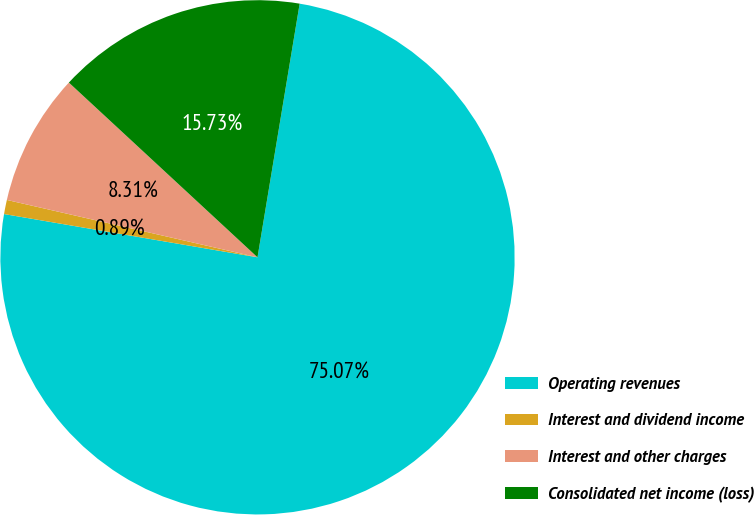Convert chart to OTSL. <chart><loc_0><loc_0><loc_500><loc_500><pie_chart><fcel>Operating revenues<fcel>Interest and dividend income<fcel>Interest and other charges<fcel>Consolidated net income (loss)<nl><fcel>75.07%<fcel>0.89%<fcel>8.31%<fcel>15.73%<nl></chart> 